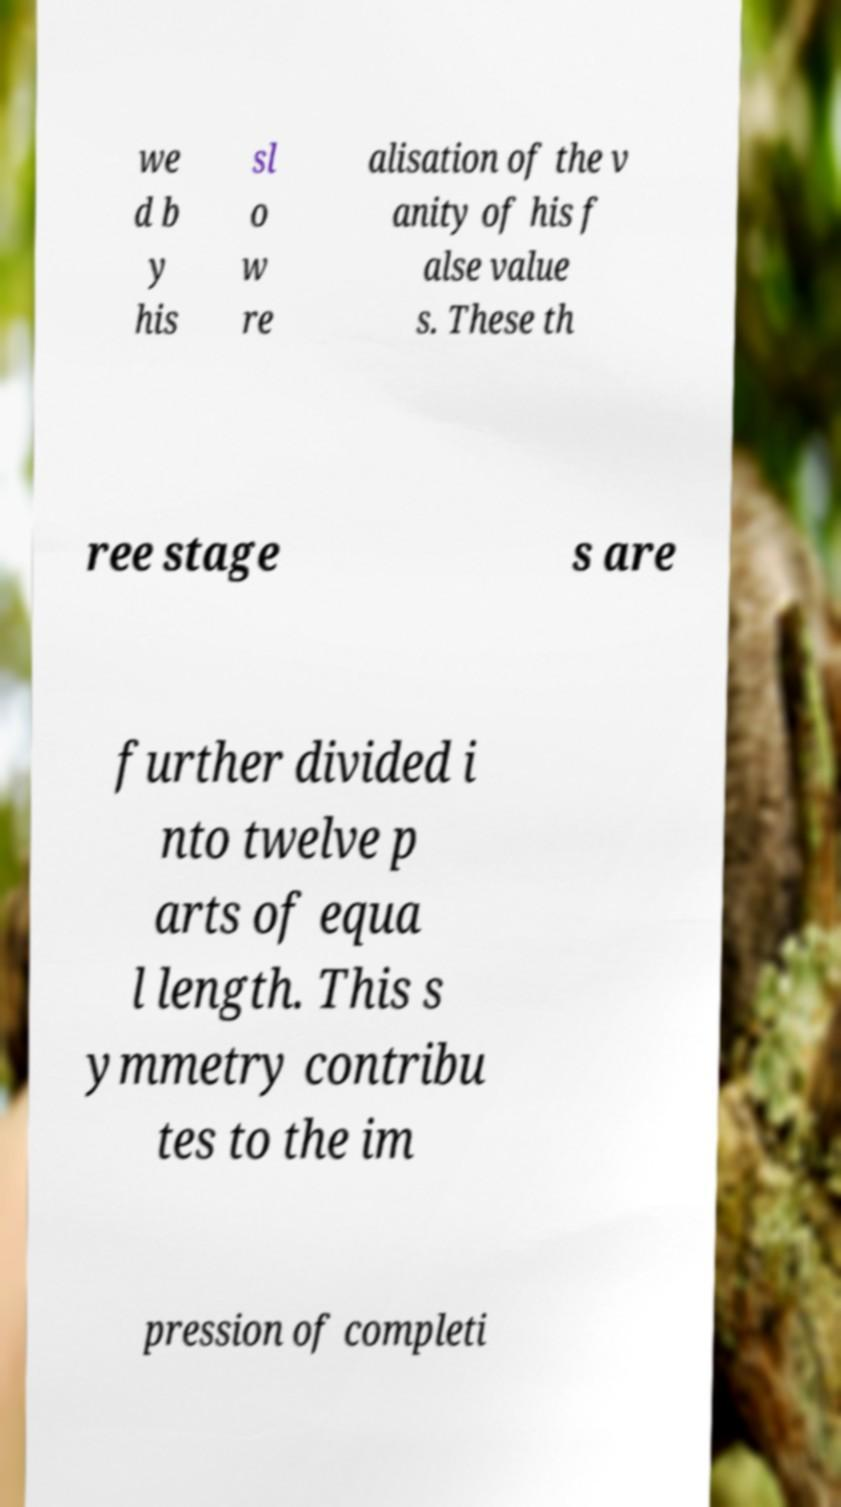There's text embedded in this image that I need extracted. Can you transcribe it verbatim? we d b y his sl o w re alisation of the v anity of his f alse value s. These th ree stage s are further divided i nto twelve p arts of equa l length. This s ymmetry contribu tes to the im pression of completi 